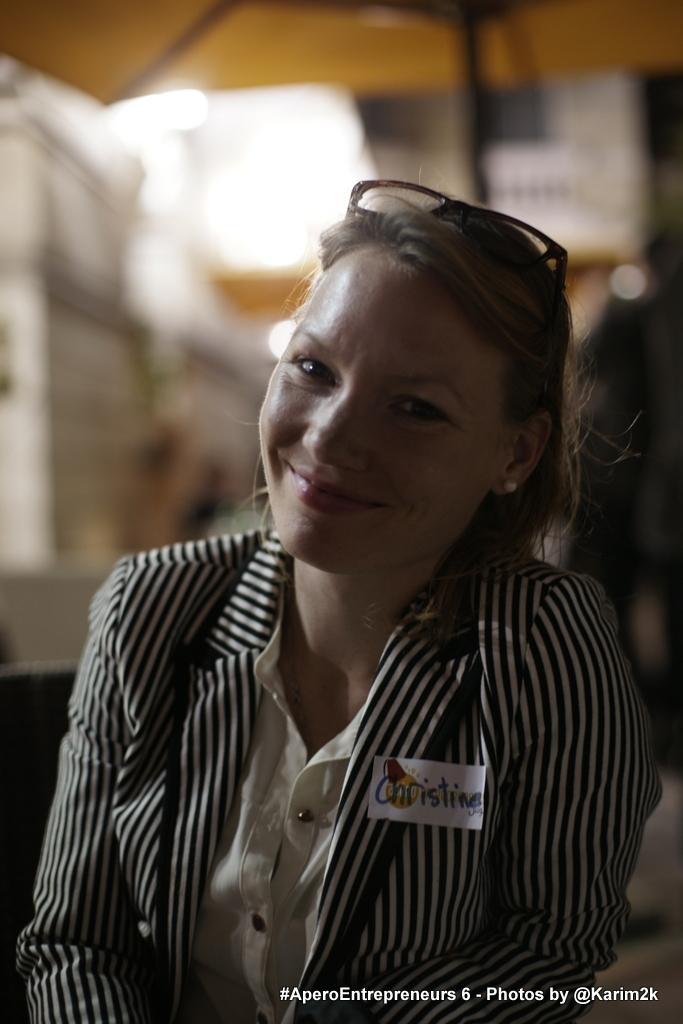Describe this image in one or two sentences. In the center of the image we can see a lady smiling. She is wearing a jacket. In the background there is a wall. 